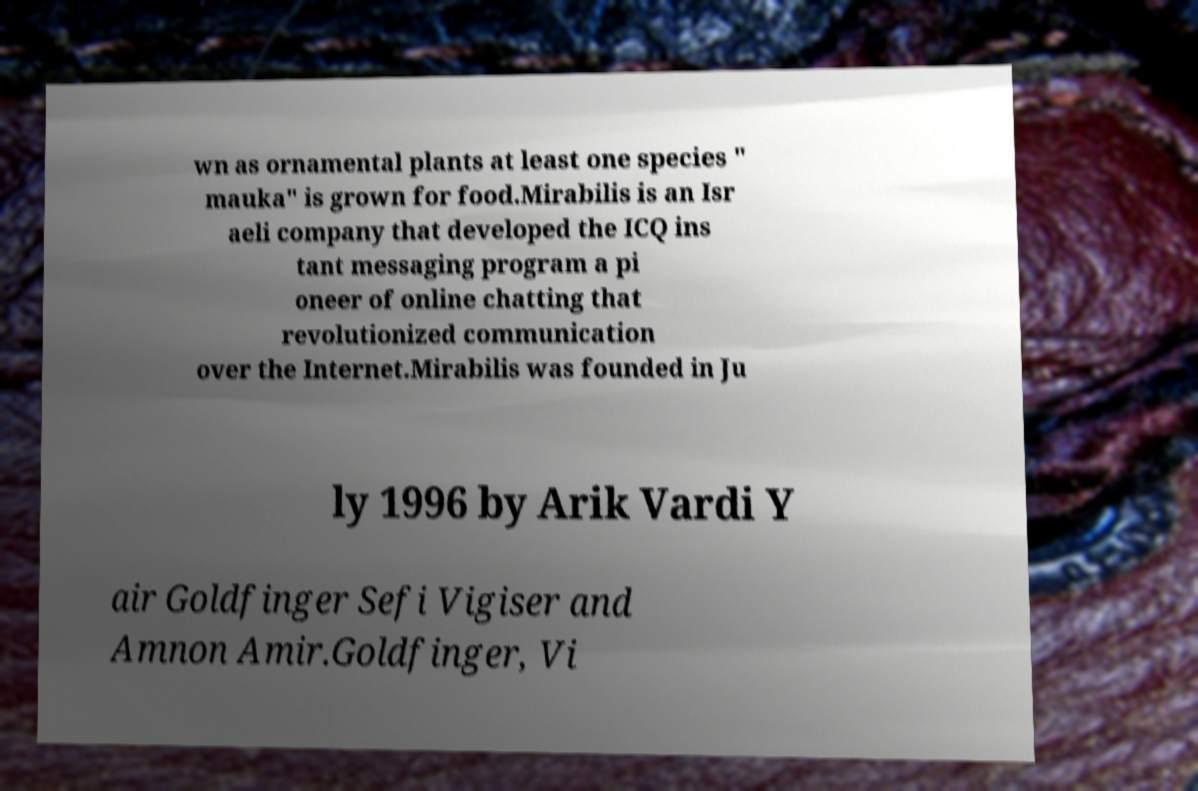Can you read and provide the text displayed in the image?This photo seems to have some interesting text. Can you extract and type it out for me? wn as ornamental plants at least one species " mauka" is grown for food.Mirabilis is an Isr aeli company that developed the ICQ ins tant messaging program a pi oneer of online chatting that revolutionized communication over the Internet.Mirabilis was founded in Ju ly 1996 by Arik Vardi Y air Goldfinger Sefi Vigiser and Amnon Amir.Goldfinger, Vi 